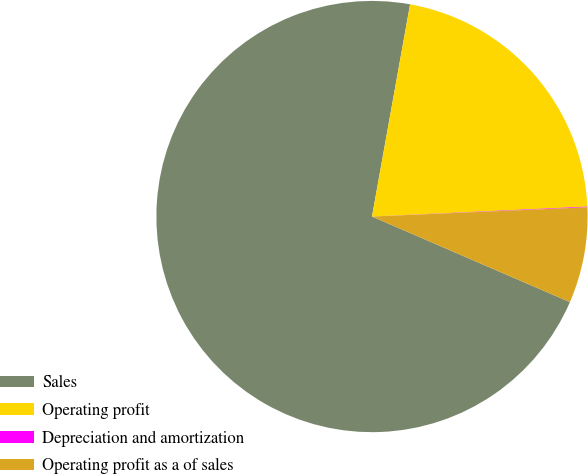Convert chart to OTSL. <chart><loc_0><loc_0><loc_500><loc_500><pie_chart><fcel>Sales<fcel>Operating profit<fcel>Depreciation and amortization<fcel>Operating profit as a of sales<nl><fcel>71.33%<fcel>21.44%<fcel>0.05%<fcel>7.18%<nl></chart> 